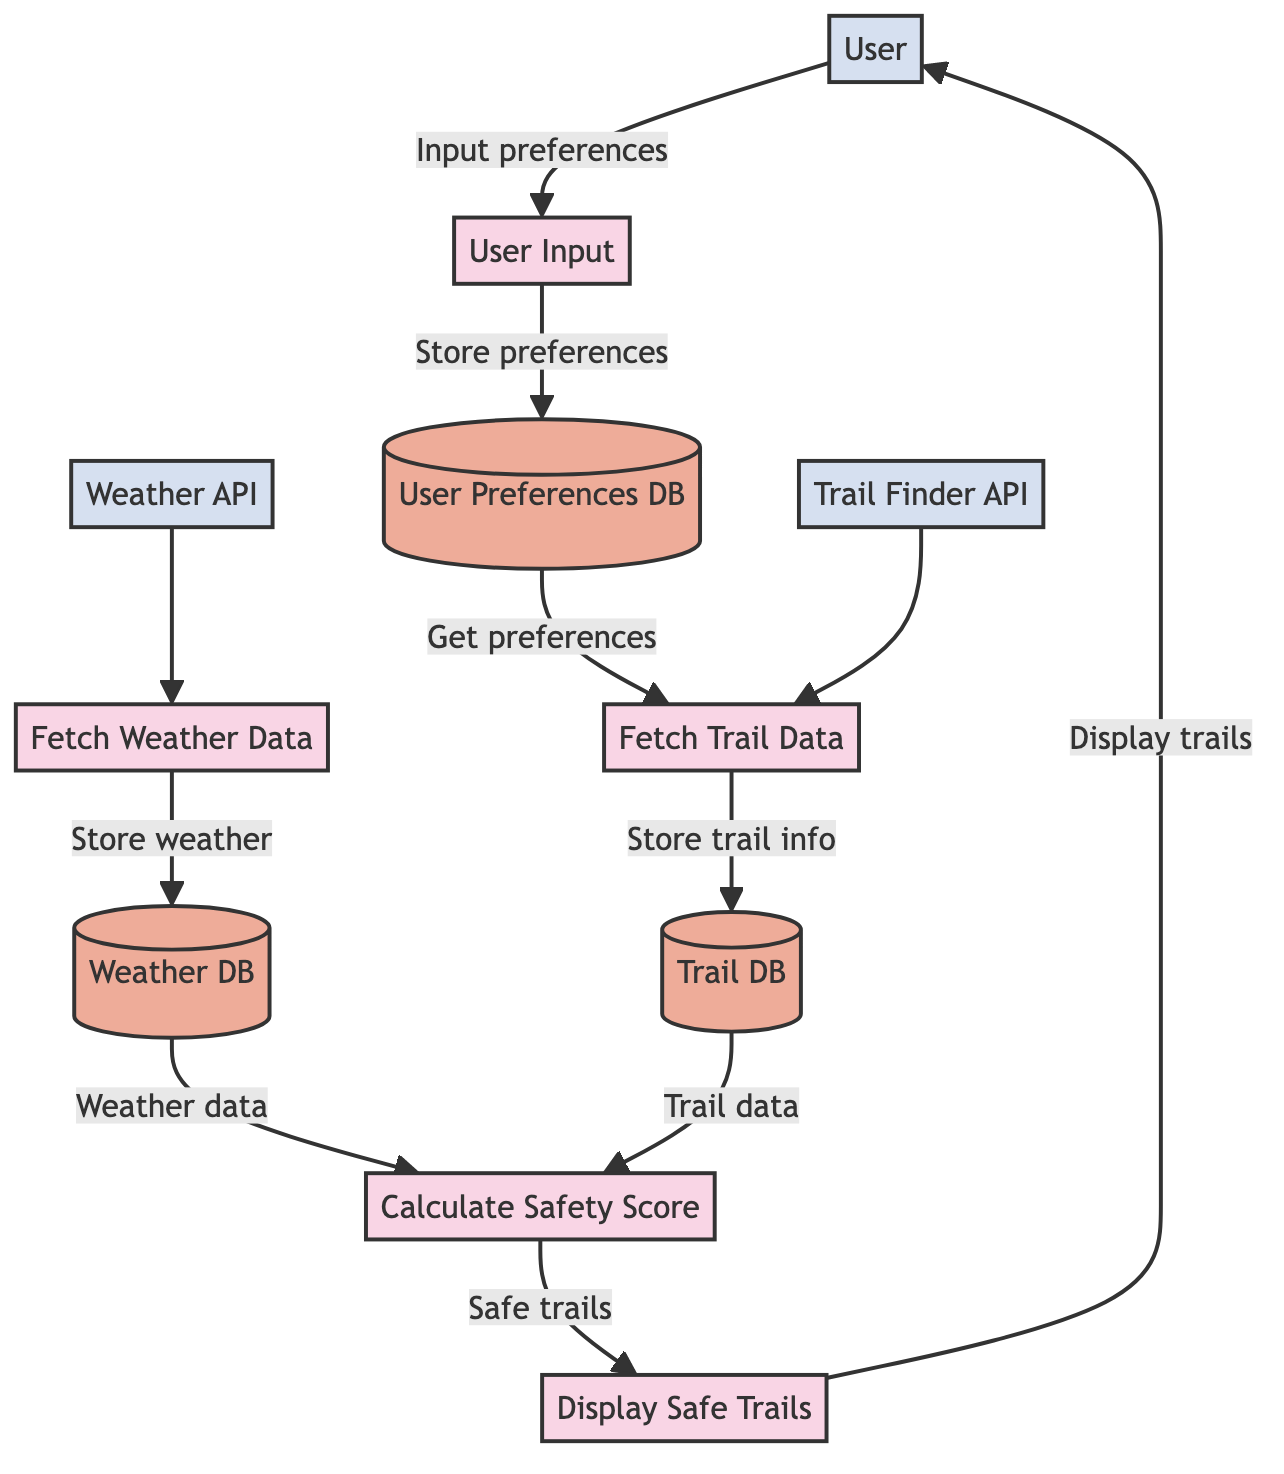What is the first process in the diagram? The first process in the diagram is where the user inputs their hiking preferences and location. This is indicated by the flow pointing from the External Entity "User" (E1) to the Process "User Input" (P1), showing it as the initiation of the data flow.
Answer: User Input How many data stores are present in the diagram? There are three data stores present in the diagram: "User Preferences Database" (D1), "Weather Database" (D2), and "Trail Database" (D3). We can count them based on the distinct datastore nodes represented in the diagram.
Answer: Three Which process retrieves weather data? The process that retrieves weather data is labeled "Fetch Weather Data" (P2). It connects directly to the "Weather API" (E2) external entity, indicating it fetches the necessary data for processing.
Answer: Fetch Weather Data What data is provided to the "Calculate Safety Score" process? The "Calculate Safety Score" (P4) process receives two types of data: "Weather data" from the "Weather Database" (D2) and "Trail data" from the "Trail Database" (D3). These data flows are indicated by the arrows leading into P4 from D2 and D3.
Answer: Weather data and Trail data What is the output of the "Display Safe Trails" process? The output of the "Display Safe Trails" (P5) process is a list of safe trails, displayed to the user. This is shown by the flow from P5 to the External Entity "User" (E1), indicating that the trails suitable for hiking are shown at this stage.
Answer: List of safe trails Which two external entities are involved in retrieving trail information? The two external entities involved in retrieving trail information are the "Weather API" (E2) and the "Trail Finder API" (E3). The relationships are shown with processes needing input from these APIs, specifically P2 for weather data and P3 for trail data.
Answer: Weather API and Trail Finder API What process stores user preferences in the database? The process that stores user preferences in the database is "User Input" (P1). After the user inputs their preferences, this is stored in the "User Preferences Database" (D1), signified by the flow from P1 to D1 in the diagram.
Answer: User Input Which data store contains weather data? The data store that contains weather data is the "Weather Database" (D2). It is specifically marked for storing the data retrieved by the "Fetch Weather Data" (P2) process, confirming its purpose as weather data storage.
Answer: Weather Database How does the "User Input" process interact with the data stores? The "User Input" (P1) process interacts with the data stores by storing user preferences in the "User Preferences Database" (D1). This is shown by the flow from P1 to D1, indicating that user inputs are recorded for future reference in the database.
Answer: Store user preferences in User Preferences Database 